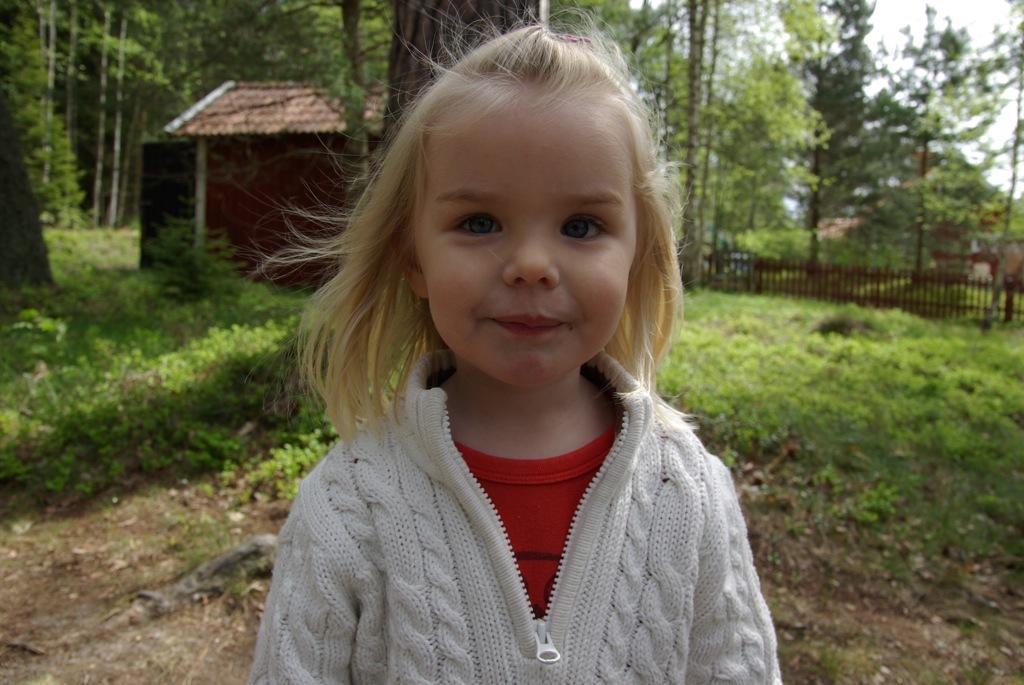How would you summarize this image in a sentence or two? In the foreground of the image we can see a girl wearing a dress. In the background, we can a fence, buildings, a group of trees, grass and the sky. 